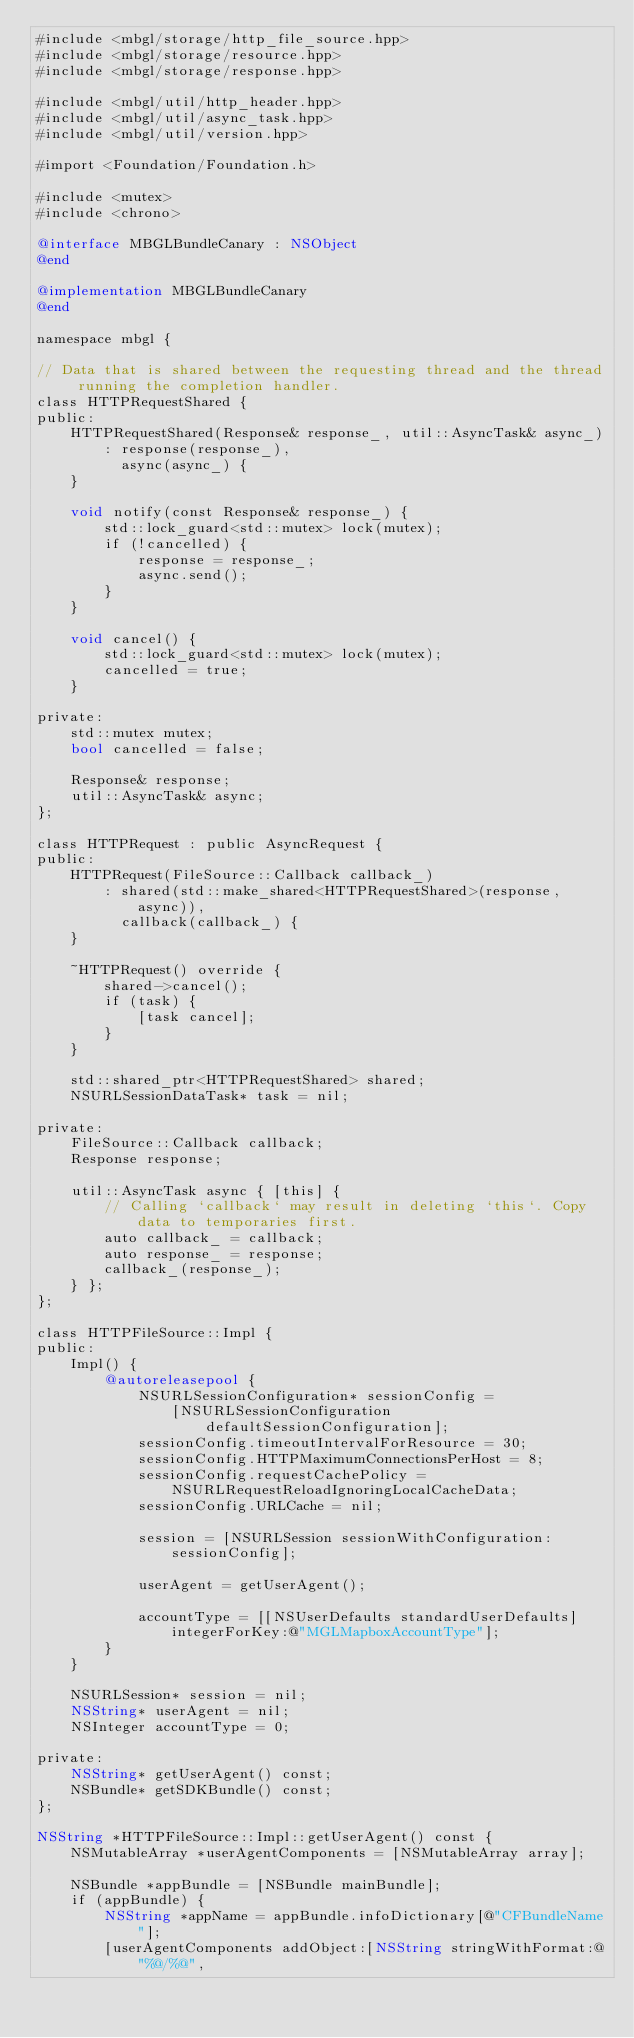Convert code to text. <code><loc_0><loc_0><loc_500><loc_500><_ObjectiveC_>#include <mbgl/storage/http_file_source.hpp>
#include <mbgl/storage/resource.hpp>
#include <mbgl/storage/response.hpp>

#include <mbgl/util/http_header.hpp>
#include <mbgl/util/async_task.hpp>
#include <mbgl/util/version.hpp>

#import <Foundation/Foundation.h>

#include <mutex>
#include <chrono>

@interface MBGLBundleCanary : NSObject
@end

@implementation MBGLBundleCanary
@end

namespace mbgl {

// Data that is shared between the requesting thread and the thread running the completion handler.
class HTTPRequestShared {
public:
    HTTPRequestShared(Response& response_, util::AsyncTask& async_)
        : response(response_),
          async(async_) {
    }

    void notify(const Response& response_) {
        std::lock_guard<std::mutex> lock(mutex);
        if (!cancelled) {
            response = response_;
            async.send();
        }
    }

    void cancel() {
        std::lock_guard<std::mutex> lock(mutex);
        cancelled = true;
    }

private:
    std::mutex mutex;
    bool cancelled = false;

    Response& response;
    util::AsyncTask& async;
};

class HTTPRequest : public AsyncRequest {
public:
    HTTPRequest(FileSource::Callback callback_)
        : shared(std::make_shared<HTTPRequestShared>(response, async)),
          callback(callback_) {
    }

    ~HTTPRequest() override {
        shared->cancel();
        if (task) {
            [task cancel];
        }
    }

    std::shared_ptr<HTTPRequestShared> shared;
    NSURLSessionDataTask* task = nil;

private:
    FileSource::Callback callback;
    Response response;

    util::AsyncTask async { [this] {
        // Calling `callback` may result in deleting `this`. Copy data to temporaries first.
        auto callback_ = callback;
        auto response_ = response;
        callback_(response_);
    } };
};

class HTTPFileSource::Impl {
public:
    Impl() {
        @autoreleasepool {
            NSURLSessionConfiguration* sessionConfig =
                [NSURLSessionConfiguration defaultSessionConfiguration];
            sessionConfig.timeoutIntervalForResource = 30;
            sessionConfig.HTTPMaximumConnectionsPerHost = 8;
            sessionConfig.requestCachePolicy = NSURLRequestReloadIgnoringLocalCacheData;
            sessionConfig.URLCache = nil;

            session = [NSURLSession sessionWithConfiguration:sessionConfig];

            userAgent = getUserAgent();

            accountType = [[NSUserDefaults standardUserDefaults] integerForKey:@"MGLMapboxAccountType"];
        }
    }

    NSURLSession* session = nil;
    NSString* userAgent = nil;
    NSInteger accountType = 0;

private:
    NSString* getUserAgent() const;
    NSBundle* getSDKBundle() const;
};

NSString *HTTPFileSource::Impl::getUserAgent() const {
    NSMutableArray *userAgentComponents = [NSMutableArray array];

    NSBundle *appBundle = [NSBundle mainBundle];
    if (appBundle) {
        NSString *appName = appBundle.infoDictionary[@"CFBundleName"];
        [userAgentComponents addObject:[NSString stringWithFormat:@"%@/%@",</code> 